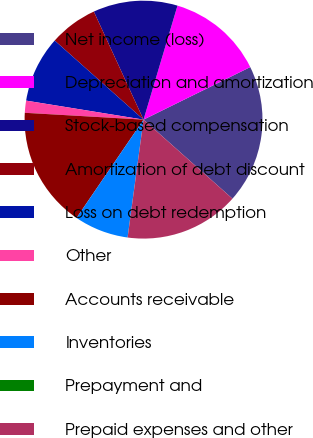<chart> <loc_0><loc_0><loc_500><loc_500><pie_chart><fcel>Net income (loss)<fcel>Depreciation and amortization<fcel>Stock-based compensation<fcel>Amortization of debt discount<fcel>Loss on debt redemption<fcel>Other<fcel>Accounts receivable<fcel>Inventories<fcel>Prepayment and<fcel>Prepaid expenses and other<nl><fcel>18.85%<fcel>13.11%<fcel>11.47%<fcel>6.56%<fcel>9.02%<fcel>1.64%<fcel>16.39%<fcel>7.38%<fcel>0.01%<fcel>15.57%<nl></chart> 